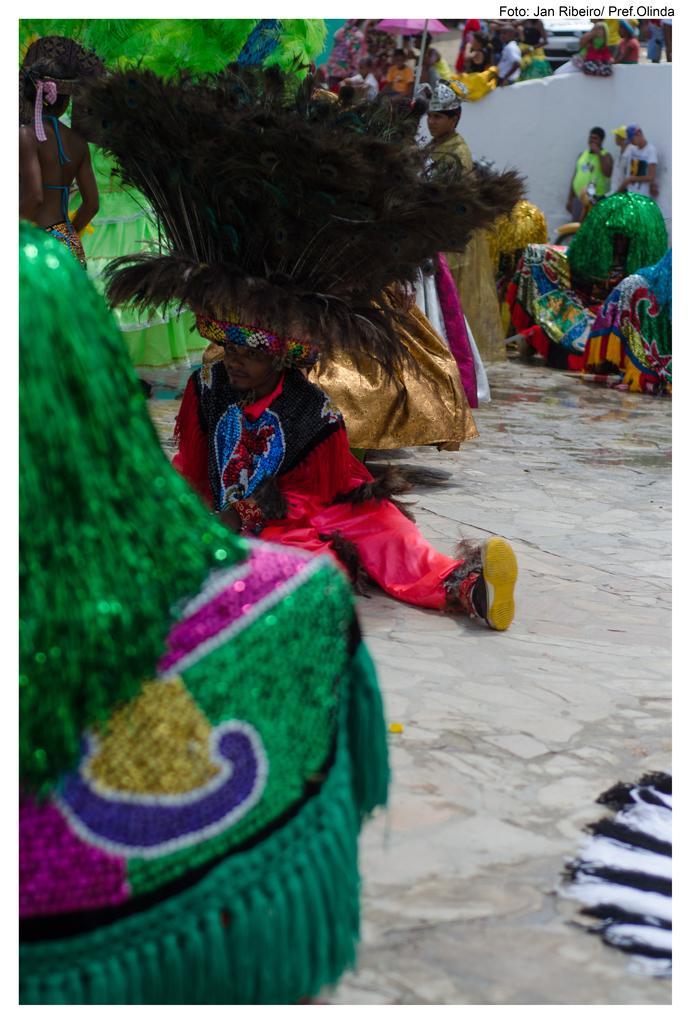How would you summarize this image in a sentence or two? In this picture we can see a group of people are in fancy dress, some people are sitting and some people are standing on the path and on the image there is a watermark. 